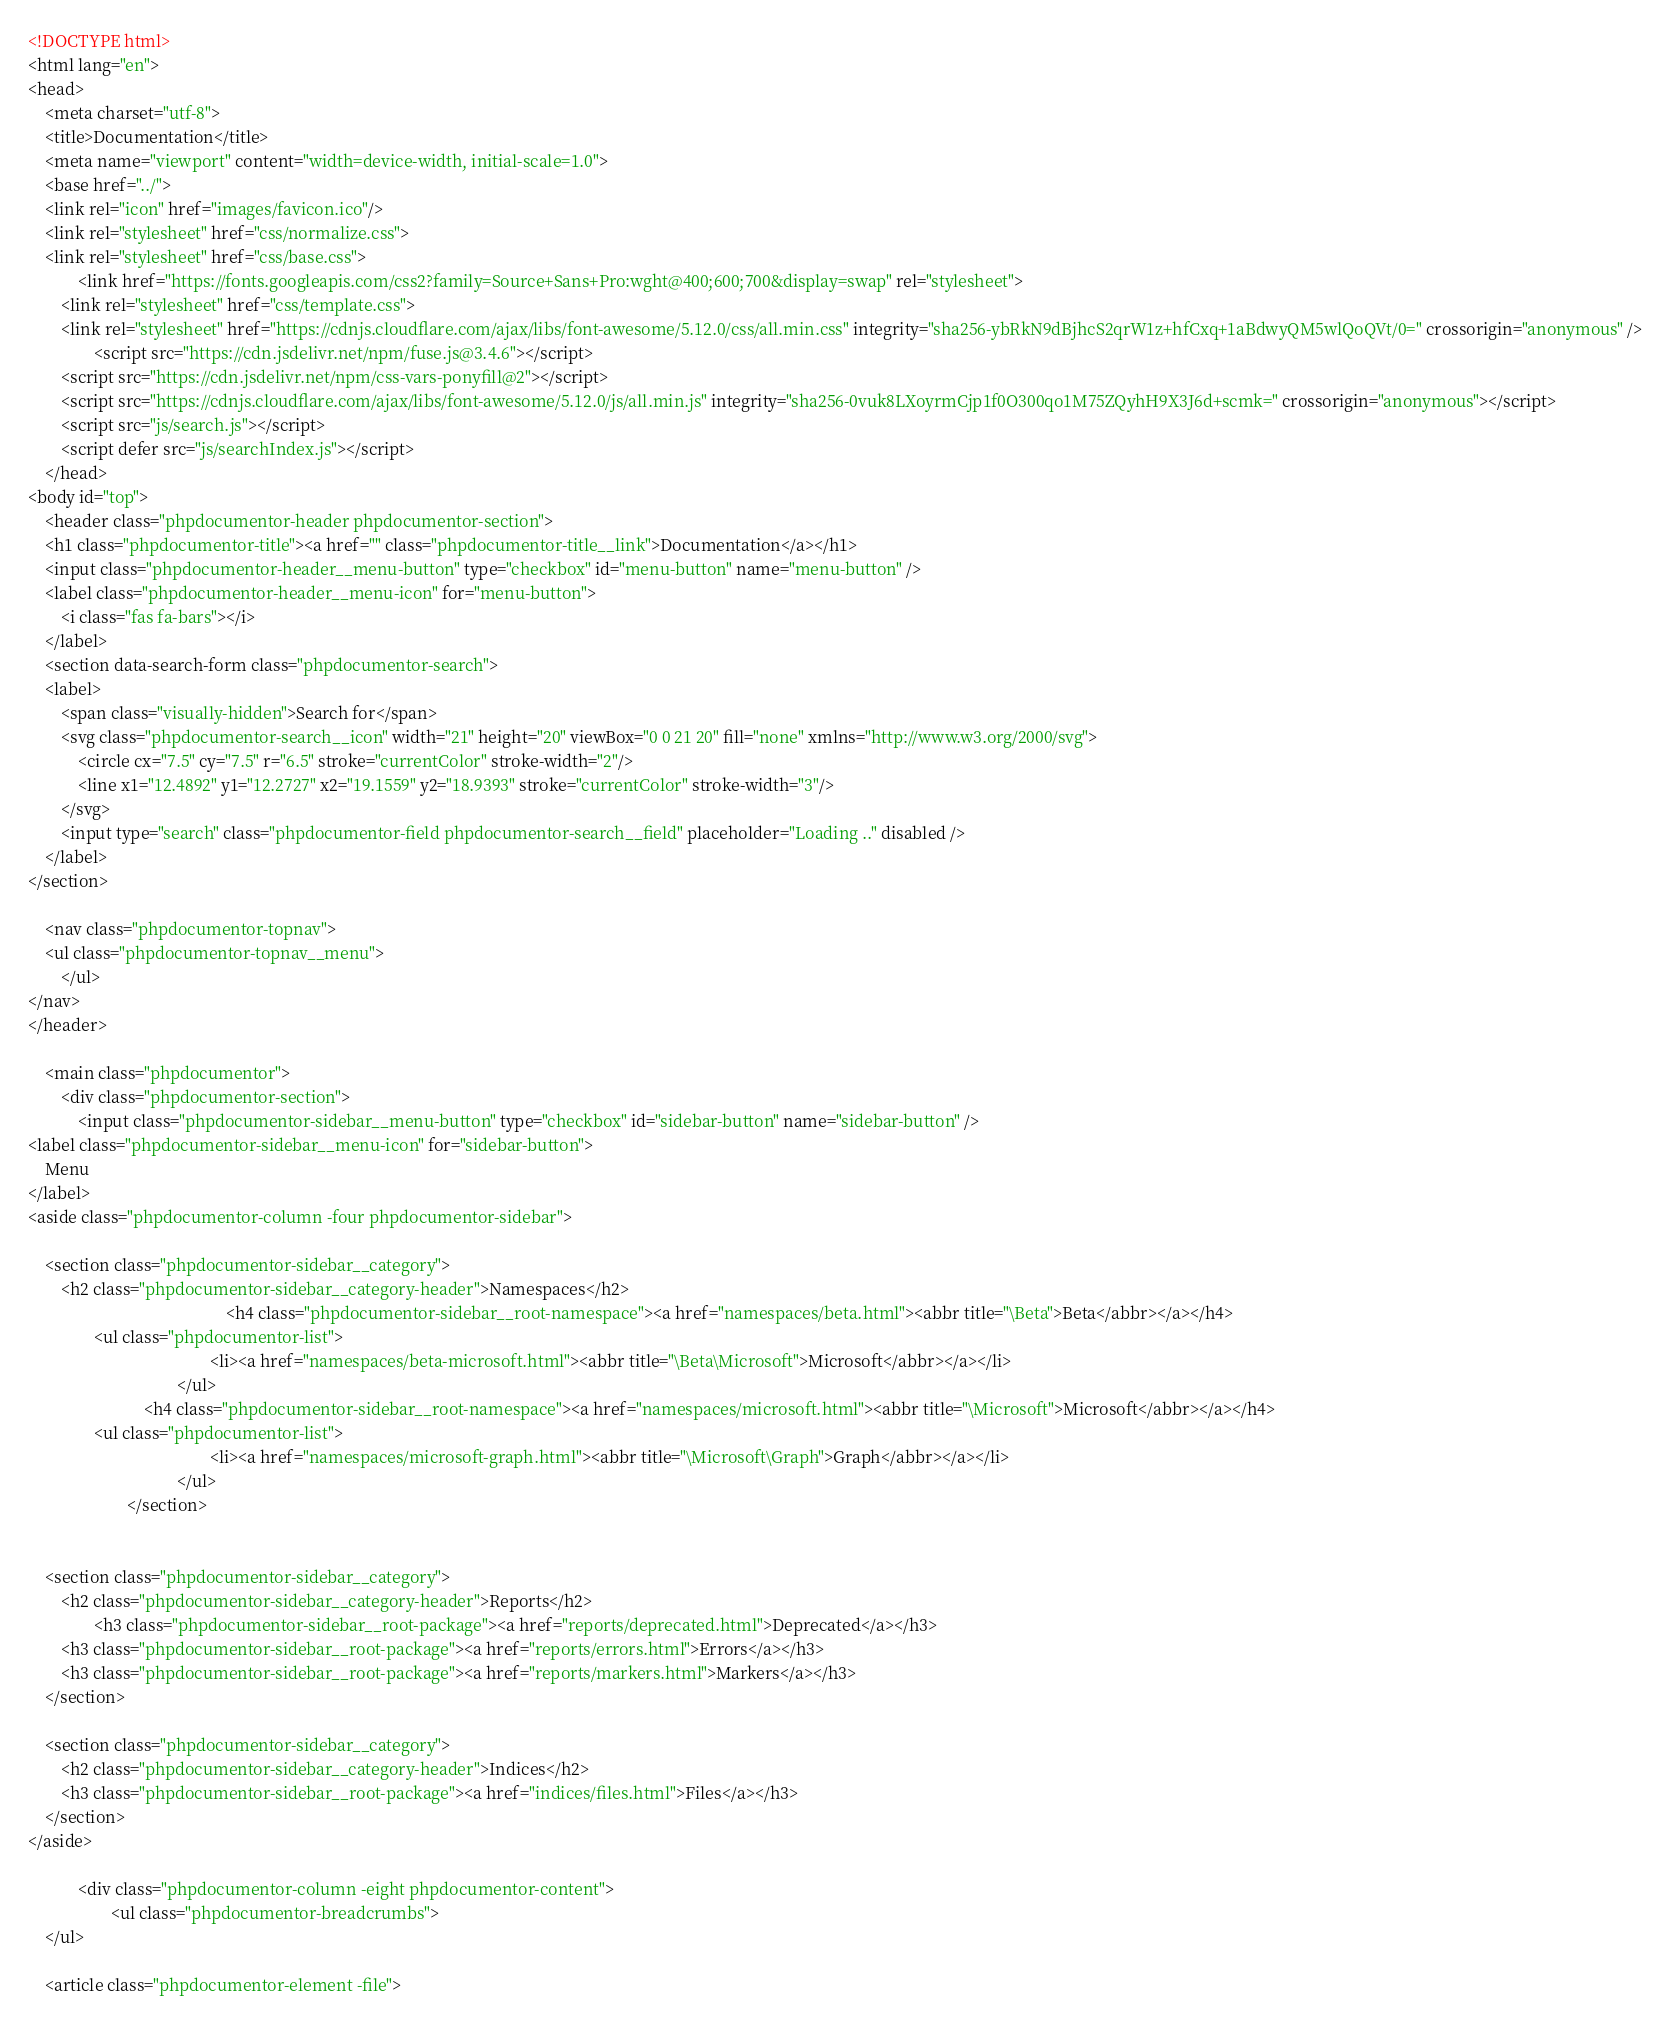<code> <loc_0><loc_0><loc_500><loc_500><_HTML_><!DOCTYPE html>
<html lang="en">
<head>
    <meta charset="utf-8">
    <title>Documentation</title>
    <meta name="viewport" content="width=device-width, initial-scale=1.0">
    <base href="../">
    <link rel="icon" href="images/favicon.ico"/>
    <link rel="stylesheet" href="css/normalize.css">
    <link rel="stylesheet" href="css/base.css">
            <link href="https://fonts.googleapis.com/css2?family=Source+Sans+Pro:wght@400;600;700&display=swap" rel="stylesheet">
        <link rel="stylesheet" href="css/template.css">
        <link rel="stylesheet" href="https://cdnjs.cloudflare.com/ajax/libs/font-awesome/5.12.0/css/all.min.css" integrity="sha256-ybRkN9dBjhcS2qrW1z+hfCxq+1aBdwyQM5wlQoQVt/0=" crossorigin="anonymous" />
                <script src="https://cdn.jsdelivr.net/npm/fuse.js@3.4.6"></script>
        <script src="https://cdn.jsdelivr.net/npm/css-vars-ponyfill@2"></script>
        <script src="https://cdnjs.cloudflare.com/ajax/libs/font-awesome/5.12.0/js/all.min.js" integrity="sha256-0vuk8LXoyrmCjp1f0O300qo1M75ZQyhH9X3J6d+scmk=" crossorigin="anonymous"></script>
        <script src="js/search.js"></script>
        <script defer src="js/searchIndex.js"></script>
    </head>
<body id="top">
    <header class="phpdocumentor-header phpdocumentor-section">
    <h1 class="phpdocumentor-title"><a href="" class="phpdocumentor-title__link">Documentation</a></h1>
    <input class="phpdocumentor-header__menu-button" type="checkbox" id="menu-button" name="menu-button" />
    <label class="phpdocumentor-header__menu-icon" for="menu-button">
        <i class="fas fa-bars"></i>
    </label>
    <section data-search-form class="phpdocumentor-search">
    <label>
        <span class="visually-hidden">Search for</span>
        <svg class="phpdocumentor-search__icon" width="21" height="20" viewBox="0 0 21 20" fill="none" xmlns="http://www.w3.org/2000/svg">
            <circle cx="7.5" cy="7.5" r="6.5" stroke="currentColor" stroke-width="2"/>
            <line x1="12.4892" y1="12.2727" x2="19.1559" y2="18.9393" stroke="currentColor" stroke-width="3"/>
        </svg>
        <input type="search" class="phpdocumentor-field phpdocumentor-search__field" placeholder="Loading .." disabled />
    </label>
</section>

    <nav class="phpdocumentor-topnav">
    <ul class="phpdocumentor-topnav__menu">
        </ul>
</nav>
</header>

    <main class="phpdocumentor">
        <div class="phpdocumentor-section">
            <input class="phpdocumentor-sidebar__menu-button" type="checkbox" id="sidebar-button" name="sidebar-button" />
<label class="phpdocumentor-sidebar__menu-icon" for="sidebar-button">
    Menu
</label>
<aside class="phpdocumentor-column -four phpdocumentor-sidebar">
    
    <section class="phpdocumentor-sidebar__category">
        <h2 class="phpdocumentor-sidebar__category-header">Namespaces</h2>
                                                <h4 class="phpdocumentor-sidebar__root-namespace"><a href="namespaces/beta.html"><abbr title="\Beta">Beta</abbr></a></h4>
                <ul class="phpdocumentor-list">
                                            <li><a href="namespaces/beta-microsoft.html"><abbr title="\Beta\Microsoft">Microsoft</abbr></a></li>
                                    </ul>
                            <h4 class="phpdocumentor-sidebar__root-namespace"><a href="namespaces/microsoft.html"><abbr title="\Microsoft">Microsoft</abbr></a></h4>
                <ul class="phpdocumentor-list">
                                            <li><a href="namespaces/microsoft-graph.html"><abbr title="\Microsoft\Graph">Graph</abbr></a></li>
                                    </ul>
                        </section>

    
    <section class="phpdocumentor-sidebar__category">
        <h2 class="phpdocumentor-sidebar__category-header">Reports</h2>
                <h3 class="phpdocumentor-sidebar__root-package"><a href="reports/deprecated.html">Deprecated</a></h3>
        <h3 class="phpdocumentor-sidebar__root-package"><a href="reports/errors.html">Errors</a></h3>
        <h3 class="phpdocumentor-sidebar__root-package"><a href="reports/markers.html">Markers</a></h3>
    </section>

    <section class="phpdocumentor-sidebar__category">
        <h2 class="phpdocumentor-sidebar__category-header">Indices</h2>
        <h3 class="phpdocumentor-sidebar__root-package"><a href="indices/files.html">Files</a></h3>
    </section>
</aside>

            <div class="phpdocumentor-column -eight phpdocumentor-content">
                    <ul class="phpdocumentor-breadcrumbs">
    </ul>

    <article class="phpdocumentor-element -file"></code> 